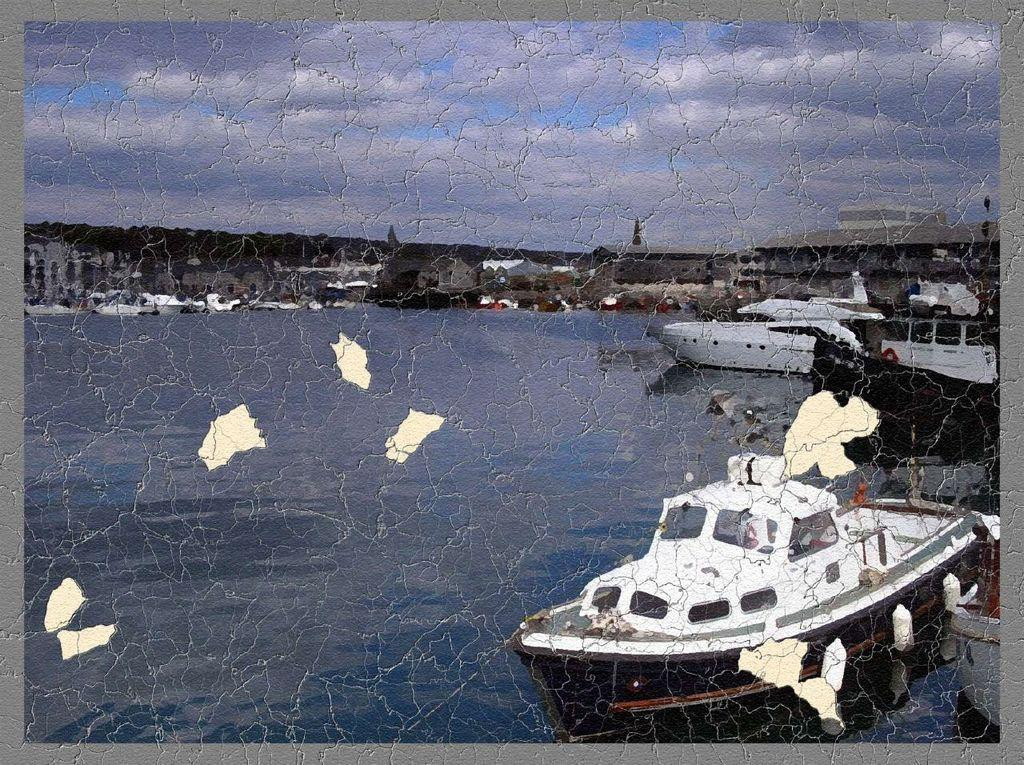What is on the water in the image? There are ships on the water in the image. What else can be seen in the image besides the ships? There are buildings, trees, and the sky visible in the image. What is the condition of the sky in the image? The sky is visible in the image, and clouds are present. What type of railway can be seen in the image? There is no railway present in the image. What sound does the tree make in the image? Trees do not make sounds, and there is no sound mentioned in the image. 